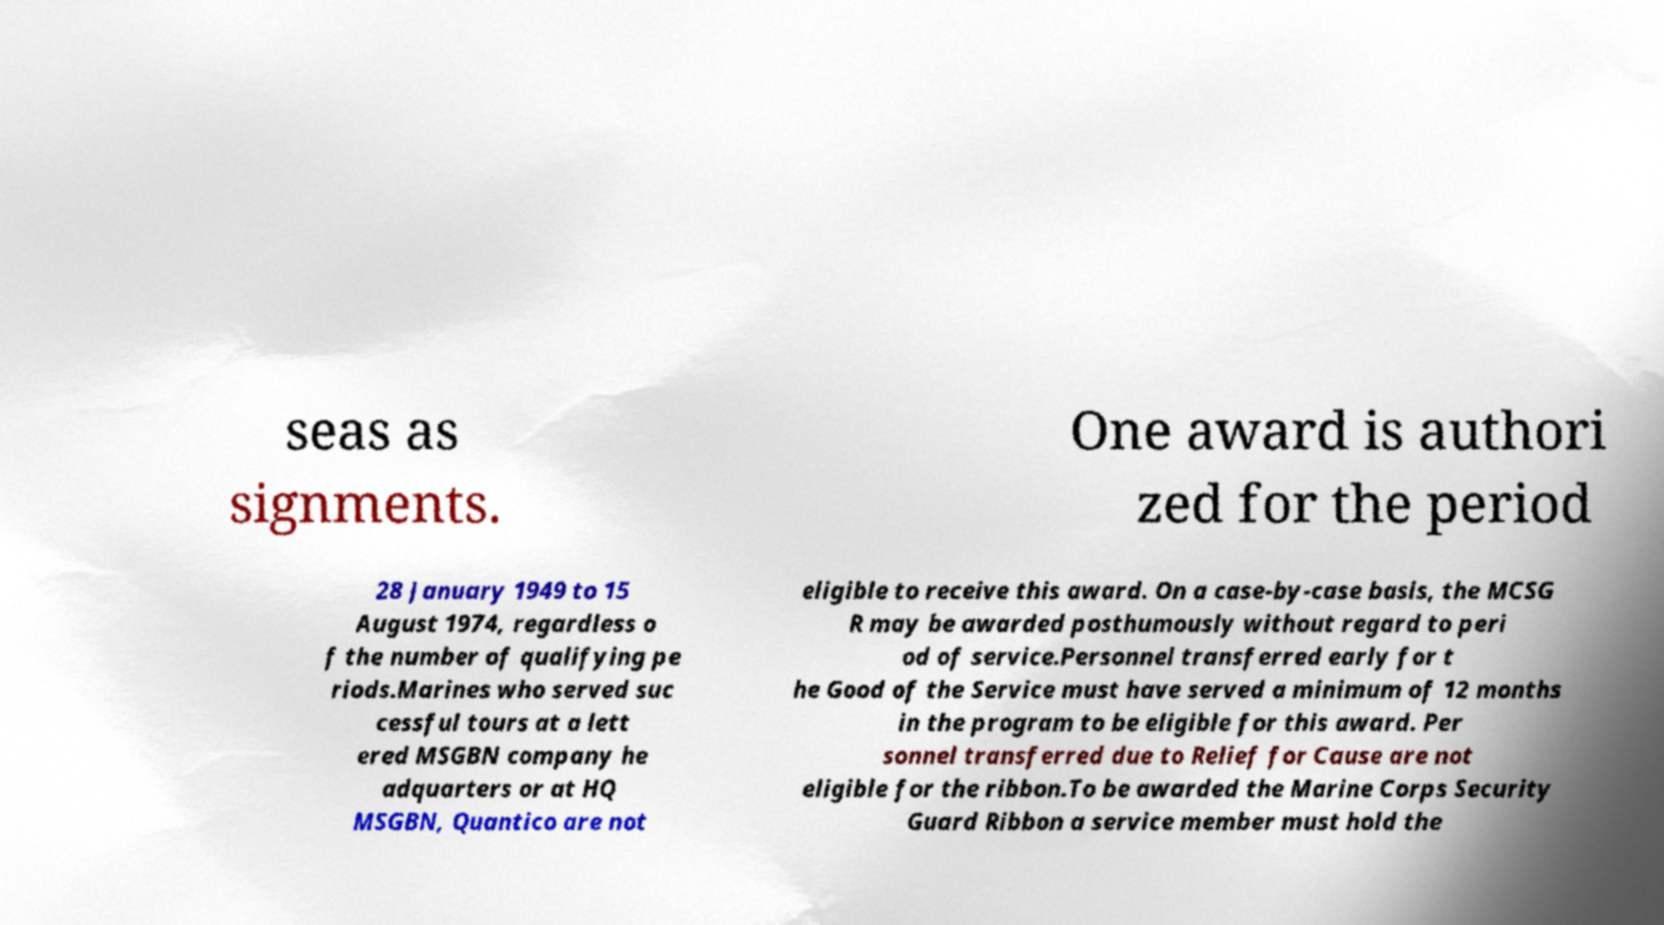For documentation purposes, I need the text within this image transcribed. Could you provide that? seas as signments. One award is authori zed for the period 28 January 1949 to 15 August 1974, regardless o f the number of qualifying pe riods.Marines who served suc cessful tours at a lett ered MSGBN company he adquarters or at HQ MSGBN, Quantico are not eligible to receive this award. On a case-by-case basis, the MCSG R may be awarded posthumously without regard to peri od of service.Personnel transferred early for t he Good of the Service must have served a minimum of 12 months in the program to be eligible for this award. Per sonnel transferred due to Relief for Cause are not eligible for the ribbon.To be awarded the Marine Corps Security Guard Ribbon a service member must hold the 